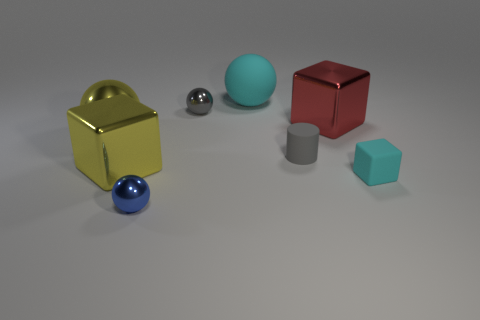There is a shiny thing that is the same color as the big metallic sphere; what is its size?
Offer a very short reply. Large. Does the block left of the tiny gray sphere have the same color as the big ball that is in front of the big red block?
Offer a very short reply. Yes. How many big cubes are the same color as the big metallic ball?
Offer a terse response. 1. Is the color of the tiny matte block the same as the matte ball?
Offer a terse response. Yes. What number of other objects are the same color as the tiny cube?
Offer a very short reply. 1. Is the number of small cylinders that are behind the big cyan rubber sphere less than the number of large spheres that are in front of the yellow metal ball?
Keep it short and to the point. No. Is there anything else that has the same shape as the gray matte thing?
Your answer should be very brief. No. What is the material of the small block that is the same color as the big matte thing?
Your answer should be compact. Rubber. How many large balls are to the right of the metal thing that is in front of the large shiny cube that is in front of the cylinder?
Keep it short and to the point. 1. How many cyan spheres are on the right side of the rubber cube?
Ensure brevity in your answer.  0. 